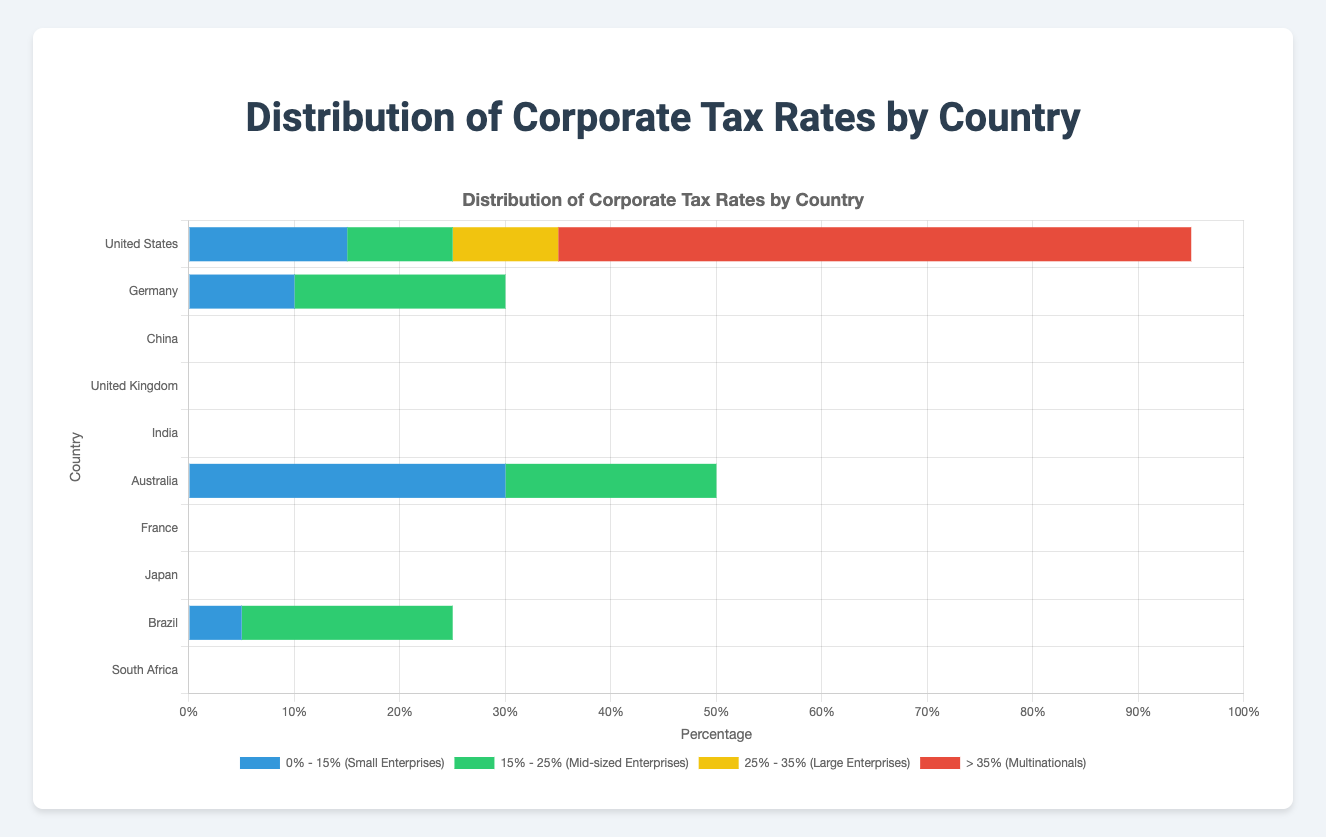What is the country with the highest percentage of multinationals taxed at more than 35%? The bar representing the United States shows the largest segment for the "> 35% (Multinationals)" category compared to other countries.
Answer: United States Which country has the smallest percentage of small enterprises taxed at 0% - 15%? Brazil's bar for the "0% - 15% (Small Enterprises)" category is the shortest among the countries that apply this tax bracket.
Answer: Brazil Compare the percentages of large enterprises taxed between 25% - 35% in the United States and Germany. Which country has a higher percentage? The bar for "25% - 35% (Large Enterprises)" in the United States covers 10%, while Germany’s corresponding category covers 30%. Thus, Germany has a higher percentage.
Answer: Germany What is the total percentage of small enterprises and mid-sized enterprises tax brackets for Australia? Australia has 30% in "0% - 15% (Small Enterprises)" and 20% in "15% - 25% (Mid-sized Enterprises)". Summing these gives 30 + 20 = 50%.
Answer: 50% Which country has a greater combined percentage for large enterprises and multinationals in the highest tax brackets? United States: 10% (Large) + 60% (>35%) = 70%. Germany: 30% (Large) + 40% (>30%) = 70%. China: 35% (Large) + 50% (>25%) = 85%. United Kingdom: 20% (Large) + 41% (>30%) = 61%. India: 20% (Large) + 60% (>33%) = 80%. Australia: 20% (Large) + 30% (>30%) = 50%. France: 30% (Large) + 30% (>33%) = 60%. Japan: 30% (Large) + 40% (>30%) = 70%. Brazil: 30% (Large) + 45% (>34%) = 75%. South Africa: 30% (Large) + 40% (>28%) = 70%. China has the greatest combined percentage.
Answer: China Which country has the percentage division among different tax brackets most skewed towards multinationals? The United States shows 60% in "> 35% (Multinationals)", which is the highest skew towards multinationals compared to other tax brackets within the country and relative to other countries.
Answer: United States Calculate the average tax bracket percentage for large enterprises across all shown countries. Large Enterprise brackets: United States: 10%, Germany: 30%, China: 35%, United Kingdom: 20%, India: 20%, Australia: 20%, France: 30%, Japan: 30%, Brazil: 30%, South Africa: 30%. Sum: 10 + 30 + 35 + 20 + 20 + 20 + 30 + 30 + 30 + 30 = 255. Average: 255 / 10 = 25.5%.
Answer: 25.5% Which country has the highest percentage of mid-sized enterprises taxed between 15% - 25%? Germany's bar for the "15% - 25% (Mid-sized Enterprises)" category is the longest among the countries using this tax range.
Answer: Germany 